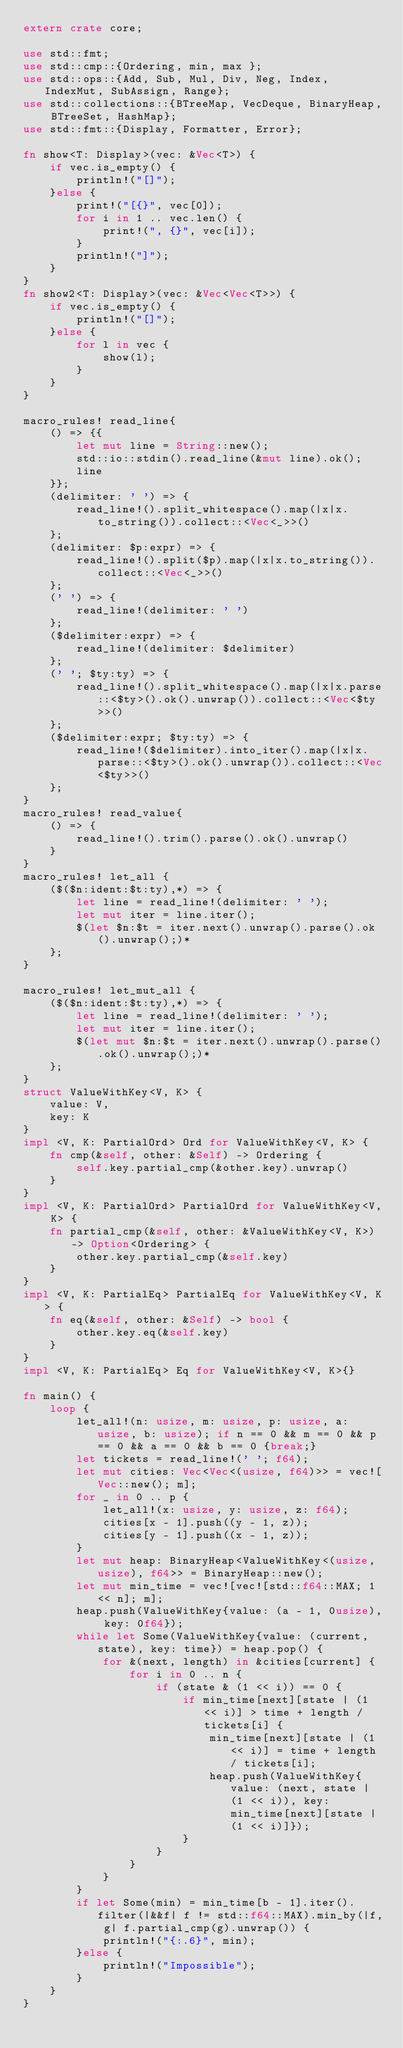<code> <loc_0><loc_0><loc_500><loc_500><_Rust_>extern crate core;

use std::fmt;
use std::cmp::{Ordering, min, max };
use std::ops::{Add, Sub, Mul, Div, Neg, Index, IndexMut, SubAssign, Range};
use std::collections::{BTreeMap, VecDeque, BinaryHeap, BTreeSet, HashMap};
use std::fmt::{Display, Formatter, Error};

fn show<T: Display>(vec: &Vec<T>) {
    if vec.is_empty() {
        println!("[]");
    }else {
        print!("[{}", vec[0]);
        for i in 1 .. vec.len() {
            print!(", {}", vec[i]);
        }
        println!("]");
    }
}
fn show2<T: Display>(vec: &Vec<Vec<T>>) {
    if vec.is_empty() {
        println!("[]");
    }else {
        for l in vec {
            show(l);
        }
    }
}

macro_rules! read_line{
    () => {{
        let mut line = String::new();
        std::io::stdin().read_line(&mut line).ok();
        line
    }};
    (delimiter: ' ') => {
        read_line!().split_whitespace().map(|x|x.to_string()).collect::<Vec<_>>()
    };
    (delimiter: $p:expr) => {
        read_line!().split($p).map(|x|x.to_string()).collect::<Vec<_>>()
    };
    (' ') => {
        read_line!(delimiter: ' ')
    };
    ($delimiter:expr) => {
        read_line!(delimiter: $delimiter)
    };
    (' '; $ty:ty) => {
        read_line!().split_whitespace().map(|x|x.parse::<$ty>().ok().unwrap()).collect::<Vec<$ty>>()
    };
    ($delimiter:expr; $ty:ty) => {
        read_line!($delimiter).into_iter().map(|x|x.parse::<$ty>().ok().unwrap()).collect::<Vec<$ty>>()
    };
}
macro_rules! read_value{
    () => {
        read_line!().trim().parse().ok().unwrap()
    }
}
macro_rules! let_all {
    ($($n:ident:$t:ty),*) => {
        let line = read_line!(delimiter: ' ');
        let mut iter = line.iter();
        $(let $n:$t = iter.next().unwrap().parse().ok().unwrap();)*
    };
}

macro_rules! let_mut_all {
    ($($n:ident:$t:ty),*) => {
        let line = read_line!(delimiter: ' ');
        let mut iter = line.iter();
        $(let mut $n:$t = iter.next().unwrap().parse().ok().unwrap();)*
    };
}
struct ValueWithKey<V, K> {
    value: V,
    key: K
}
impl <V, K: PartialOrd> Ord for ValueWithKey<V, K> {
    fn cmp(&self, other: &Self) -> Ordering {
        self.key.partial_cmp(&other.key).unwrap()
    }
}
impl <V, K: PartialOrd> PartialOrd for ValueWithKey<V, K> {
    fn partial_cmp(&self, other: &ValueWithKey<V, K>) -> Option<Ordering> {
        other.key.partial_cmp(&self.key)
    }
}
impl <V, K: PartialEq> PartialEq for ValueWithKey<V, K> {
    fn eq(&self, other: &Self) -> bool {
        other.key.eq(&self.key)
    }
}
impl <V, K: PartialEq> Eq for ValueWithKey<V, K>{}

fn main() {
    loop {
        let_all!(n: usize, m: usize, p: usize, a: usize, b: usize); if n == 0 && m == 0 && p == 0 && a == 0 && b == 0 {break;}
        let tickets = read_line!(' '; f64);
        let mut cities: Vec<Vec<(usize, f64)>> = vec![Vec::new(); m];
        for _ in 0 .. p {
            let_all!(x: usize, y: usize, z: f64);
            cities[x - 1].push((y - 1, z));
            cities[y - 1].push((x - 1, z));
        }
        let mut heap: BinaryHeap<ValueWithKey<(usize, usize), f64>> = BinaryHeap::new();
        let mut min_time = vec![vec![std::f64::MAX; 1 << n]; m];
        heap.push(ValueWithKey{value: (a - 1, 0usize), key: 0f64});
        while let Some(ValueWithKey{value: (current, state), key: time}) = heap.pop() {
            for &(next, length) in &cities[current] {
                for i in 0 .. n {
                    if (state & (1 << i)) == 0 {
                        if min_time[next][state | (1 << i)] > time + length / tickets[i] {
                            min_time[next][state | (1 << i)] = time + length / tickets[i];
                            heap.push(ValueWithKey{value: (next, state | (1 << i)), key: min_time[next][state | (1 << i)]});
                        }
                    }
                }
            }
        }
        if let Some(min) = min_time[b - 1].iter().filter(|&&f| f != std::f64::MAX).min_by(|f, g| f.partial_cmp(g).unwrap()) {
            println!("{:.6}", min);
        }else {
            println!("Impossible");
        }
    }
}

</code> 